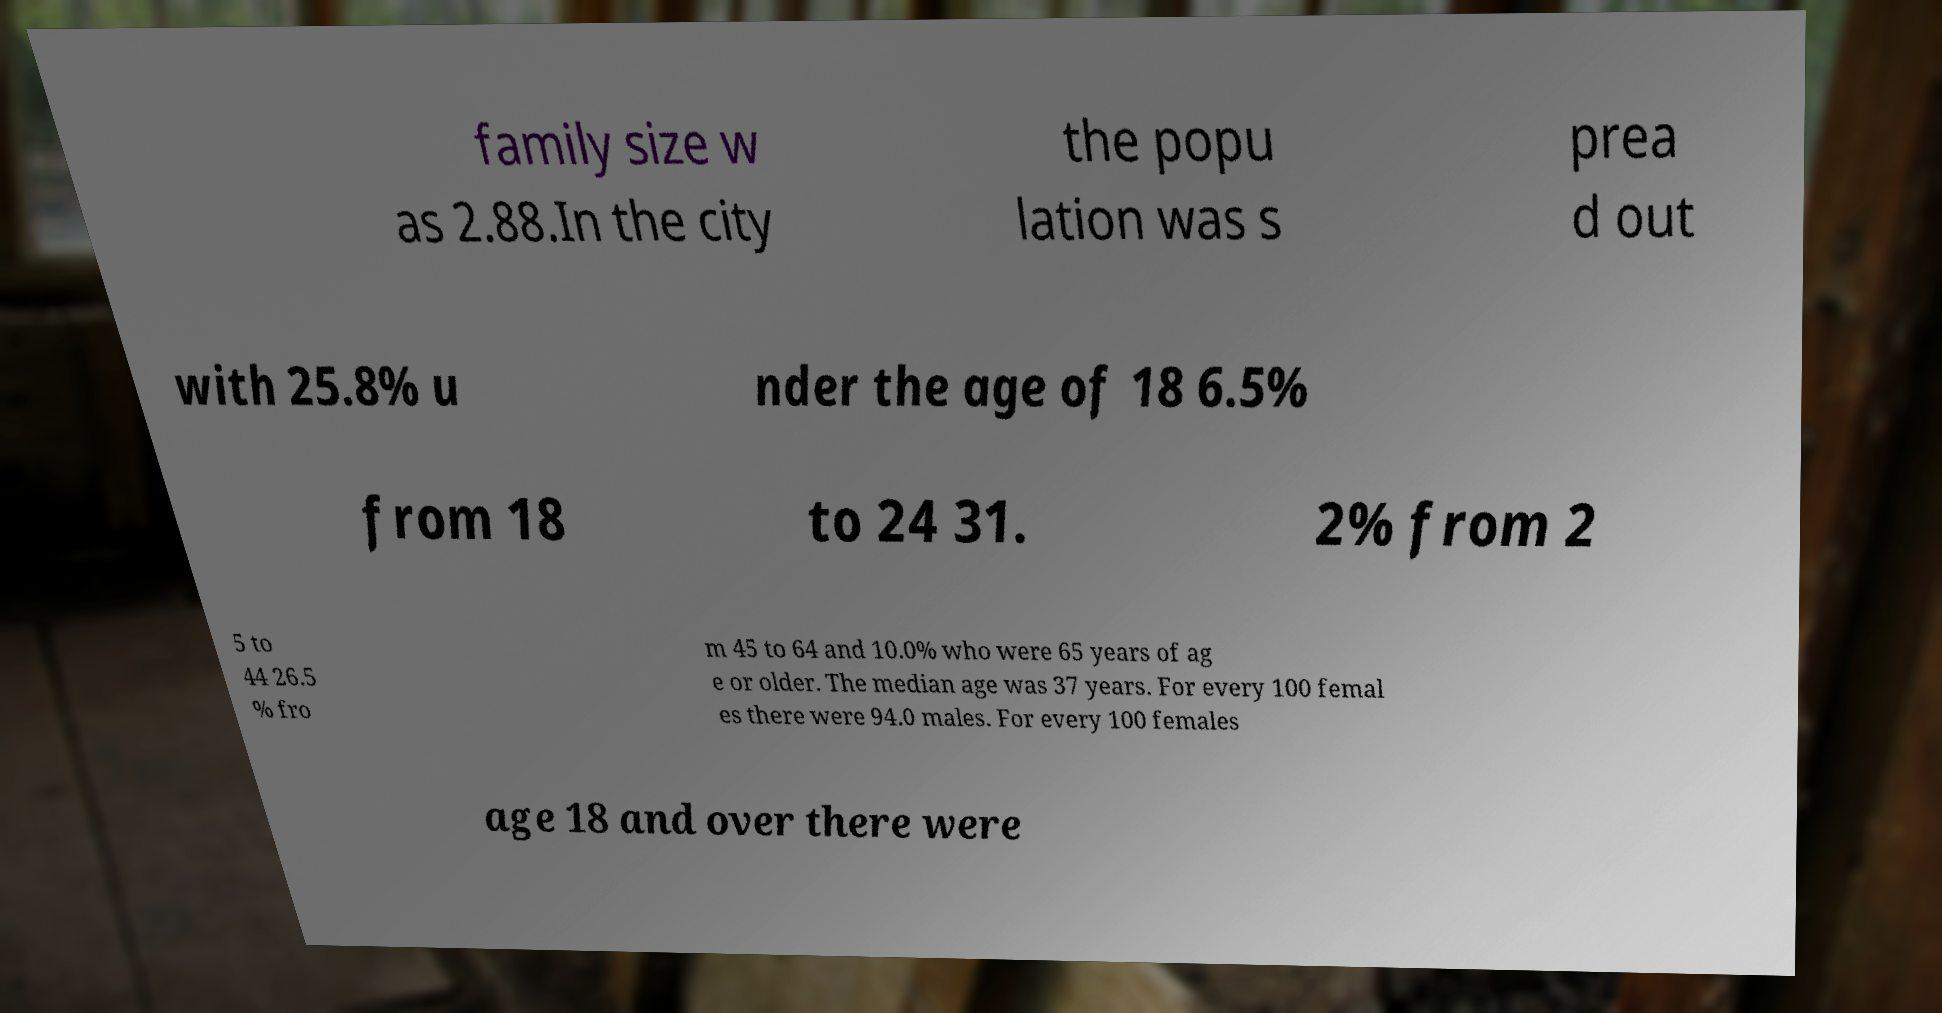I need the written content from this picture converted into text. Can you do that? family size w as 2.88.In the city the popu lation was s prea d out with 25.8% u nder the age of 18 6.5% from 18 to 24 31. 2% from 2 5 to 44 26.5 % fro m 45 to 64 and 10.0% who were 65 years of ag e or older. The median age was 37 years. For every 100 femal es there were 94.0 males. For every 100 females age 18 and over there were 